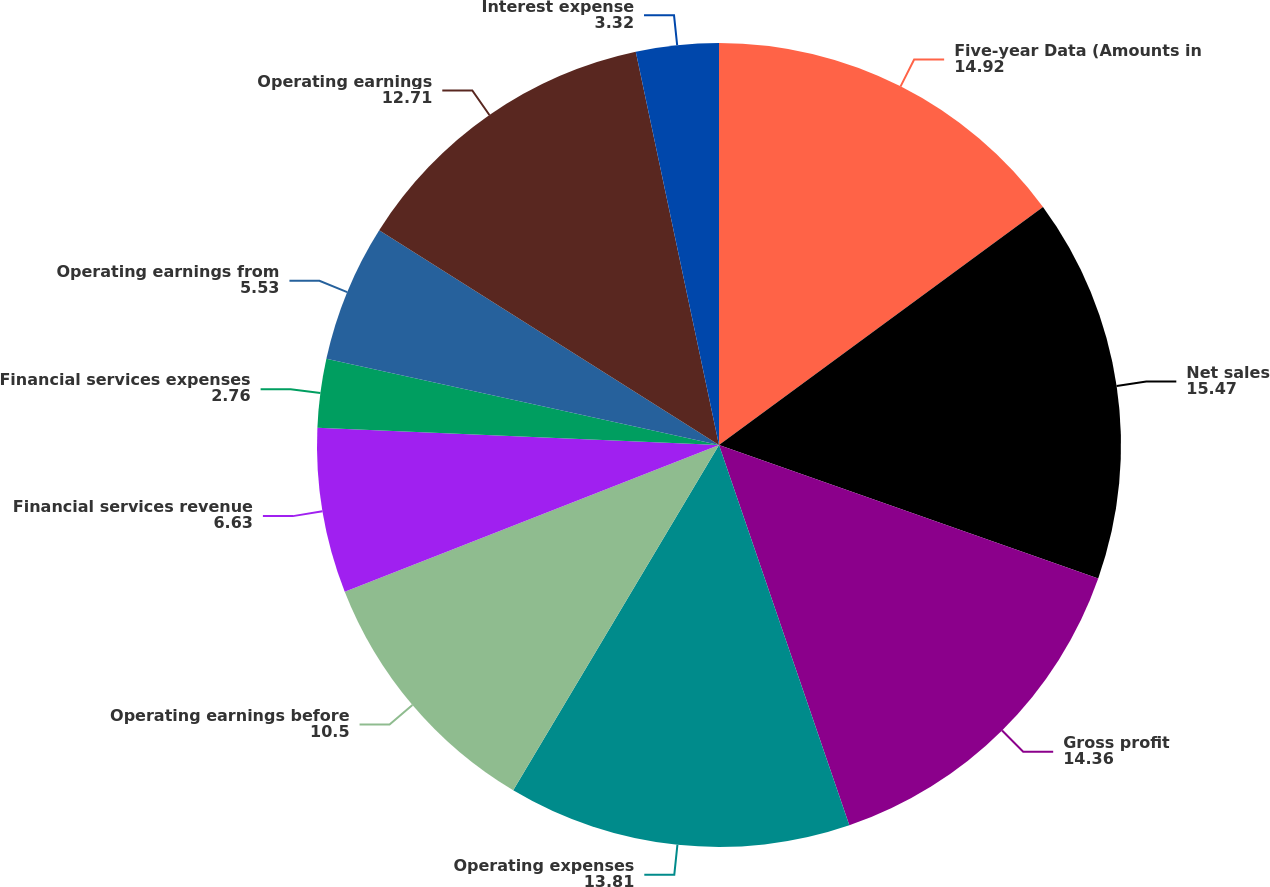Convert chart. <chart><loc_0><loc_0><loc_500><loc_500><pie_chart><fcel>Five-year Data (Amounts in<fcel>Net sales<fcel>Gross profit<fcel>Operating expenses<fcel>Operating earnings before<fcel>Financial services revenue<fcel>Financial services expenses<fcel>Operating earnings from<fcel>Operating earnings<fcel>Interest expense<nl><fcel>14.92%<fcel>15.47%<fcel>14.36%<fcel>13.81%<fcel>10.5%<fcel>6.63%<fcel>2.76%<fcel>5.53%<fcel>12.71%<fcel>3.32%<nl></chart> 